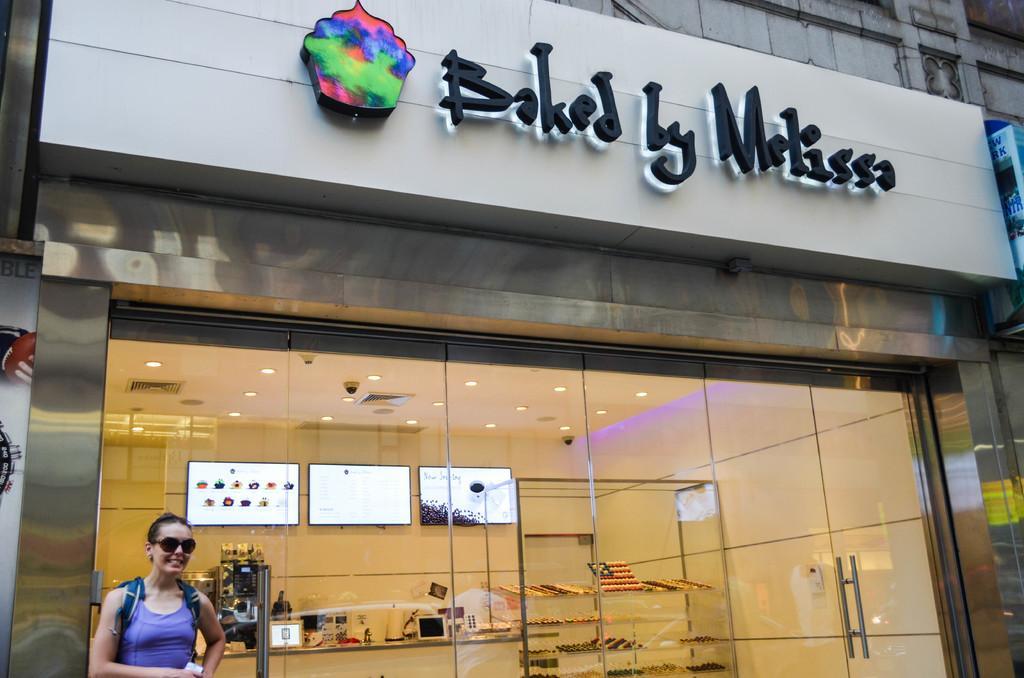Can you describe this image briefly? In this image we can see a building. We can also see the televisions on a wall, some objects placed on the racks, some devices and objects placed on a table and a roof with some ceiling lights. We can also see an illuminated signboard. In the foreground we can see a woman. 